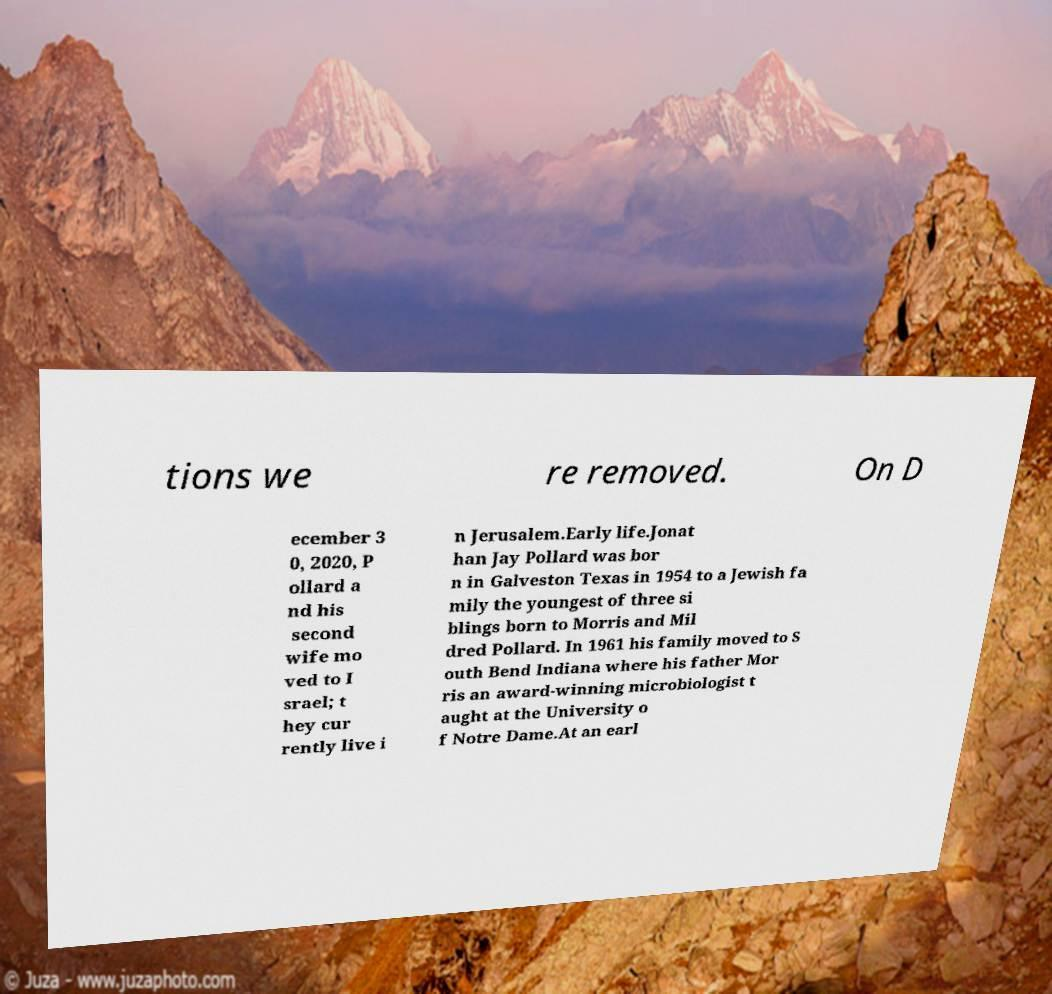Could you extract and type out the text from this image? tions we re removed. On D ecember 3 0, 2020, P ollard a nd his second wife mo ved to I srael; t hey cur rently live i n Jerusalem.Early life.Jonat han Jay Pollard was bor n in Galveston Texas in 1954 to a Jewish fa mily the youngest of three si blings born to Morris and Mil dred Pollard. In 1961 his family moved to S outh Bend Indiana where his father Mor ris an award-winning microbiologist t aught at the University o f Notre Dame.At an earl 